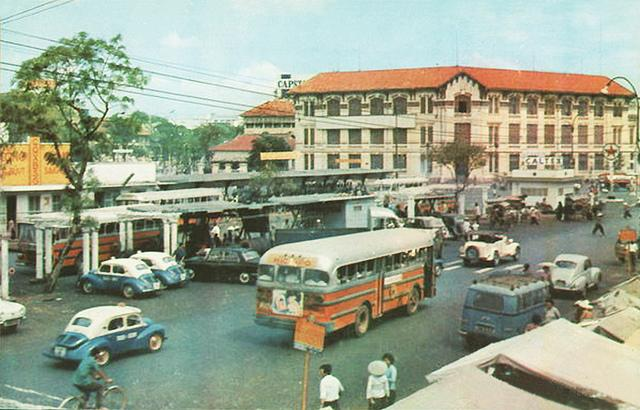What is the name of the gas station with the red star? texaco 